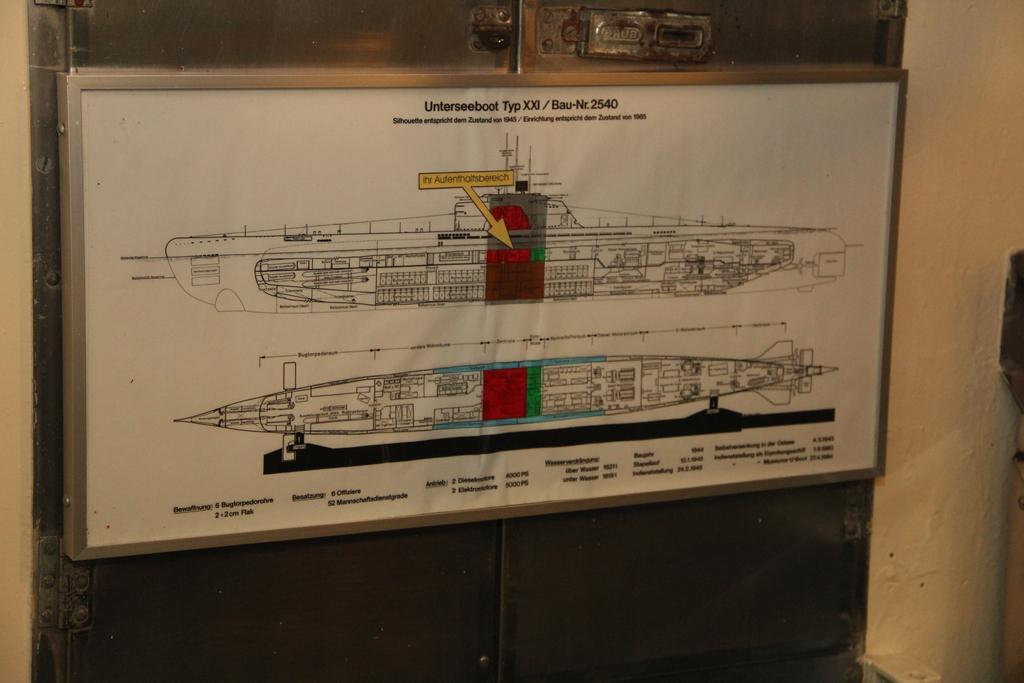Describe this image in one or two sentences. In this image I can see a white colour board and on it I can see two sketches. I can also see something is written on the board. 